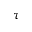<formula> <loc_0><loc_0><loc_500><loc_500>\tau</formula> 